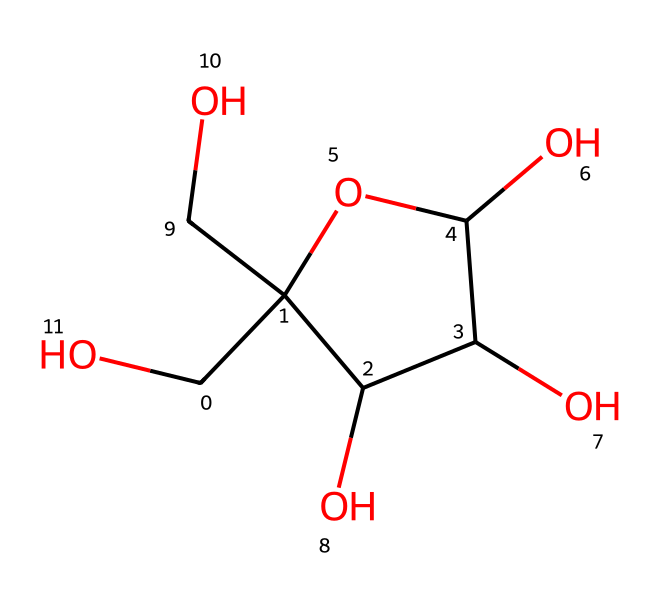What is the molecular formula of fructose represented by this SMILES? The SMILES indicates that fructose consists of 6 carbon (C) atoms, 12 hydrogen (H) atoms, and 6 oxygen (O) atoms. So, the molecular formula can be derived as C6H12O6.
Answer: C6H12O6 How many hydroxyl (−OH) groups are present in the structure of fructose? By analyzing the structure, you can count the number of hydroxyl (−OH) groups. There are five -OH groups attached to the carbon atoms in the structure of fructose.
Answer: five What type of carbohydrate is fructose classified as? Fructose is classified as a monosaccharide due to its single sugar unit structure. It contains a simple sugar structure with no further hydrolysis products.
Answer: monosaccharide Which specific structural feature of fructose contributes to its sweet taste? Fructose has a unique arrangement of hydroxyl groups and a ketone functional group, contributing to its higher sweetness compared to other sugars. The specific arrangement allows better interaction with sweet taste receptors.
Answer: ketone group What is the total number of carbon atoms in the structure of fructose? The visual representation or the SMILES allows us to easily identify that there are 6 carbon atoms in the fructose structure.
Answer: six How does the presence of a ketone group affect the reactivity of fructose? The ketone group in fructose makes it more reactive than regular aldehyde sugars because it can participate in different types of reactions such as reductions and isomerizations. Ketone functionality increases the range of reactions fructose can undergo, compared to aldehydes.
Answer: increases reactivity 